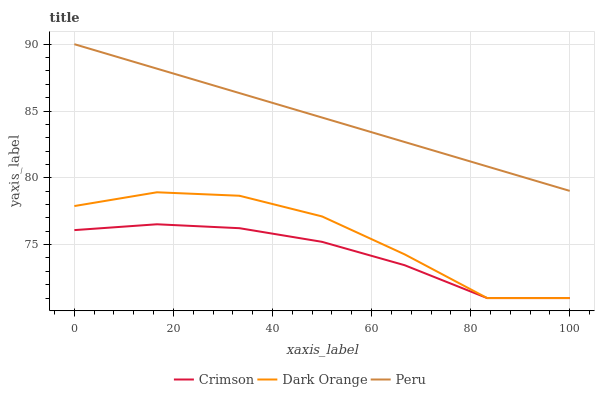Does Crimson have the minimum area under the curve?
Answer yes or no. Yes. Does Peru have the maximum area under the curve?
Answer yes or no. Yes. Does Dark Orange have the minimum area under the curve?
Answer yes or no. No. Does Dark Orange have the maximum area under the curve?
Answer yes or no. No. Is Peru the smoothest?
Answer yes or no. Yes. Is Dark Orange the roughest?
Answer yes or no. Yes. Is Dark Orange the smoothest?
Answer yes or no. No. Is Peru the roughest?
Answer yes or no. No. Does Crimson have the lowest value?
Answer yes or no. Yes. Does Peru have the lowest value?
Answer yes or no. No. Does Peru have the highest value?
Answer yes or no. Yes. Does Dark Orange have the highest value?
Answer yes or no. No. Is Dark Orange less than Peru?
Answer yes or no. Yes. Is Peru greater than Crimson?
Answer yes or no. Yes. Does Crimson intersect Dark Orange?
Answer yes or no. Yes. Is Crimson less than Dark Orange?
Answer yes or no. No. Is Crimson greater than Dark Orange?
Answer yes or no. No. Does Dark Orange intersect Peru?
Answer yes or no. No. 